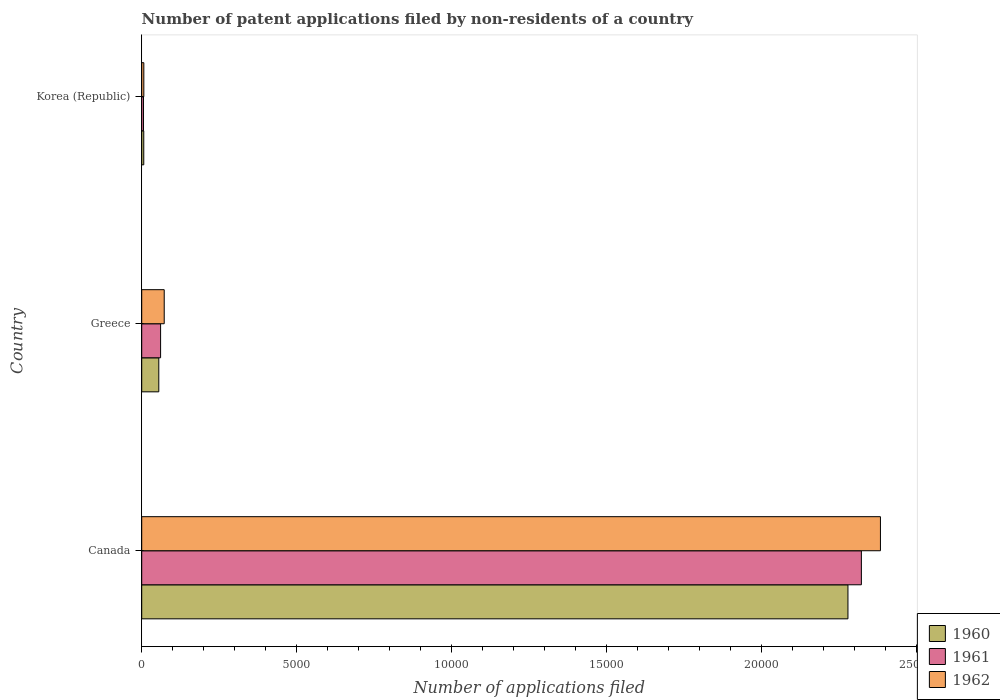How many different coloured bars are there?
Give a very brief answer. 3. Are the number of bars per tick equal to the number of legend labels?
Ensure brevity in your answer.  Yes. What is the label of the 3rd group of bars from the top?
Ensure brevity in your answer.  Canada. What is the number of applications filed in 1961 in Greece?
Give a very brief answer. 609. Across all countries, what is the maximum number of applications filed in 1962?
Keep it short and to the point. 2.38e+04. In which country was the number of applications filed in 1960 maximum?
Give a very brief answer. Canada. What is the total number of applications filed in 1960 in the graph?
Your response must be concise. 2.34e+04. What is the difference between the number of applications filed in 1961 in Greece and that in Korea (Republic)?
Offer a terse response. 551. What is the difference between the number of applications filed in 1960 in Canada and the number of applications filed in 1961 in Korea (Republic)?
Make the answer very short. 2.27e+04. What is the average number of applications filed in 1960 per country?
Provide a short and direct response. 7801. What is the difference between the number of applications filed in 1960 and number of applications filed in 1962 in Korea (Republic)?
Ensure brevity in your answer.  -2. What is the ratio of the number of applications filed in 1962 in Greece to that in Korea (Republic)?
Your response must be concise. 10.68. Is the number of applications filed in 1962 in Canada less than that in Greece?
Provide a succinct answer. No. Is the difference between the number of applications filed in 1960 in Greece and Korea (Republic) greater than the difference between the number of applications filed in 1962 in Greece and Korea (Republic)?
Give a very brief answer. No. What is the difference between the highest and the second highest number of applications filed in 1961?
Ensure brevity in your answer.  2.26e+04. What is the difference between the highest and the lowest number of applications filed in 1960?
Keep it short and to the point. 2.27e+04. Is the sum of the number of applications filed in 1962 in Canada and Korea (Republic) greater than the maximum number of applications filed in 1960 across all countries?
Give a very brief answer. Yes. Is it the case that in every country, the sum of the number of applications filed in 1962 and number of applications filed in 1960 is greater than the number of applications filed in 1961?
Offer a very short reply. Yes. Are all the bars in the graph horizontal?
Offer a very short reply. Yes. Does the graph contain any zero values?
Give a very brief answer. No. Does the graph contain grids?
Your response must be concise. No. Where does the legend appear in the graph?
Make the answer very short. Bottom right. How many legend labels are there?
Your answer should be very brief. 3. How are the legend labels stacked?
Your response must be concise. Vertical. What is the title of the graph?
Provide a succinct answer. Number of patent applications filed by non-residents of a country. Does "1984" appear as one of the legend labels in the graph?
Provide a short and direct response. No. What is the label or title of the X-axis?
Ensure brevity in your answer.  Number of applications filed. What is the label or title of the Y-axis?
Provide a short and direct response. Country. What is the Number of applications filed of 1960 in Canada?
Your answer should be very brief. 2.28e+04. What is the Number of applications filed of 1961 in Canada?
Offer a very short reply. 2.32e+04. What is the Number of applications filed in 1962 in Canada?
Your answer should be compact. 2.38e+04. What is the Number of applications filed of 1960 in Greece?
Your response must be concise. 551. What is the Number of applications filed of 1961 in Greece?
Your response must be concise. 609. What is the Number of applications filed of 1962 in Greece?
Your answer should be very brief. 726. What is the Number of applications filed of 1962 in Korea (Republic)?
Your answer should be compact. 68. Across all countries, what is the maximum Number of applications filed of 1960?
Keep it short and to the point. 2.28e+04. Across all countries, what is the maximum Number of applications filed of 1961?
Give a very brief answer. 2.32e+04. Across all countries, what is the maximum Number of applications filed in 1962?
Your answer should be compact. 2.38e+04. Across all countries, what is the minimum Number of applications filed of 1961?
Ensure brevity in your answer.  58. Across all countries, what is the minimum Number of applications filed in 1962?
Ensure brevity in your answer.  68. What is the total Number of applications filed in 1960 in the graph?
Offer a very short reply. 2.34e+04. What is the total Number of applications filed of 1961 in the graph?
Your response must be concise. 2.39e+04. What is the total Number of applications filed of 1962 in the graph?
Ensure brevity in your answer.  2.46e+04. What is the difference between the Number of applications filed in 1960 in Canada and that in Greece?
Keep it short and to the point. 2.22e+04. What is the difference between the Number of applications filed in 1961 in Canada and that in Greece?
Your answer should be very brief. 2.26e+04. What is the difference between the Number of applications filed in 1962 in Canada and that in Greece?
Your answer should be very brief. 2.31e+04. What is the difference between the Number of applications filed in 1960 in Canada and that in Korea (Republic)?
Your response must be concise. 2.27e+04. What is the difference between the Number of applications filed of 1961 in Canada and that in Korea (Republic)?
Keep it short and to the point. 2.32e+04. What is the difference between the Number of applications filed of 1962 in Canada and that in Korea (Republic)?
Your response must be concise. 2.38e+04. What is the difference between the Number of applications filed in 1960 in Greece and that in Korea (Republic)?
Keep it short and to the point. 485. What is the difference between the Number of applications filed of 1961 in Greece and that in Korea (Republic)?
Keep it short and to the point. 551. What is the difference between the Number of applications filed in 1962 in Greece and that in Korea (Republic)?
Your answer should be compact. 658. What is the difference between the Number of applications filed in 1960 in Canada and the Number of applications filed in 1961 in Greece?
Make the answer very short. 2.22e+04. What is the difference between the Number of applications filed in 1960 in Canada and the Number of applications filed in 1962 in Greece?
Ensure brevity in your answer.  2.21e+04. What is the difference between the Number of applications filed in 1961 in Canada and the Number of applications filed in 1962 in Greece?
Provide a short and direct response. 2.25e+04. What is the difference between the Number of applications filed of 1960 in Canada and the Number of applications filed of 1961 in Korea (Republic)?
Make the answer very short. 2.27e+04. What is the difference between the Number of applications filed of 1960 in Canada and the Number of applications filed of 1962 in Korea (Republic)?
Provide a short and direct response. 2.27e+04. What is the difference between the Number of applications filed of 1961 in Canada and the Number of applications filed of 1962 in Korea (Republic)?
Offer a very short reply. 2.32e+04. What is the difference between the Number of applications filed of 1960 in Greece and the Number of applications filed of 1961 in Korea (Republic)?
Provide a succinct answer. 493. What is the difference between the Number of applications filed of 1960 in Greece and the Number of applications filed of 1962 in Korea (Republic)?
Offer a very short reply. 483. What is the difference between the Number of applications filed in 1961 in Greece and the Number of applications filed in 1962 in Korea (Republic)?
Give a very brief answer. 541. What is the average Number of applications filed in 1960 per country?
Provide a succinct answer. 7801. What is the average Number of applications filed of 1961 per country?
Provide a succinct answer. 7962. What is the average Number of applications filed in 1962 per country?
Your answer should be compact. 8209.33. What is the difference between the Number of applications filed of 1960 and Number of applications filed of 1961 in Canada?
Your response must be concise. -433. What is the difference between the Number of applications filed in 1960 and Number of applications filed in 1962 in Canada?
Your response must be concise. -1048. What is the difference between the Number of applications filed in 1961 and Number of applications filed in 1962 in Canada?
Your response must be concise. -615. What is the difference between the Number of applications filed of 1960 and Number of applications filed of 1961 in Greece?
Your answer should be compact. -58. What is the difference between the Number of applications filed of 1960 and Number of applications filed of 1962 in Greece?
Provide a succinct answer. -175. What is the difference between the Number of applications filed of 1961 and Number of applications filed of 1962 in Greece?
Make the answer very short. -117. What is the difference between the Number of applications filed in 1960 and Number of applications filed in 1961 in Korea (Republic)?
Give a very brief answer. 8. What is the difference between the Number of applications filed of 1960 and Number of applications filed of 1962 in Korea (Republic)?
Your answer should be very brief. -2. What is the ratio of the Number of applications filed of 1960 in Canada to that in Greece?
Your answer should be very brief. 41.35. What is the ratio of the Number of applications filed in 1961 in Canada to that in Greece?
Keep it short and to the point. 38.13. What is the ratio of the Number of applications filed in 1962 in Canada to that in Greece?
Your answer should be very brief. 32.83. What is the ratio of the Number of applications filed in 1960 in Canada to that in Korea (Republic)?
Offer a very short reply. 345.24. What is the ratio of the Number of applications filed in 1961 in Canada to that in Korea (Republic)?
Your answer should be very brief. 400.33. What is the ratio of the Number of applications filed of 1962 in Canada to that in Korea (Republic)?
Your answer should be compact. 350.5. What is the ratio of the Number of applications filed in 1960 in Greece to that in Korea (Republic)?
Provide a short and direct response. 8.35. What is the ratio of the Number of applications filed in 1961 in Greece to that in Korea (Republic)?
Ensure brevity in your answer.  10.5. What is the ratio of the Number of applications filed in 1962 in Greece to that in Korea (Republic)?
Your response must be concise. 10.68. What is the difference between the highest and the second highest Number of applications filed of 1960?
Provide a succinct answer. 2.22e+04. What is the difference between the highest and the second highest Number of applications filed in 1961?
Offer a terse response. 2.26e+04. What is the difference between the highest and the second highest Number of applications filed in 1962?
Your answer should be very brief. 2.31e+04. What is the difference between the highest and the lowest Number of applications filed in 1960?
Give a very brief answer. 2.27e+04. What is the difference between the highest and the lowest Number of applications filed of 1961?
Your answer should be very brief. 2.32e+04. What is the difference between the highest and the lowest Number of applications filed of 1962?
Provide a succinct answer. 2.38e+04. 